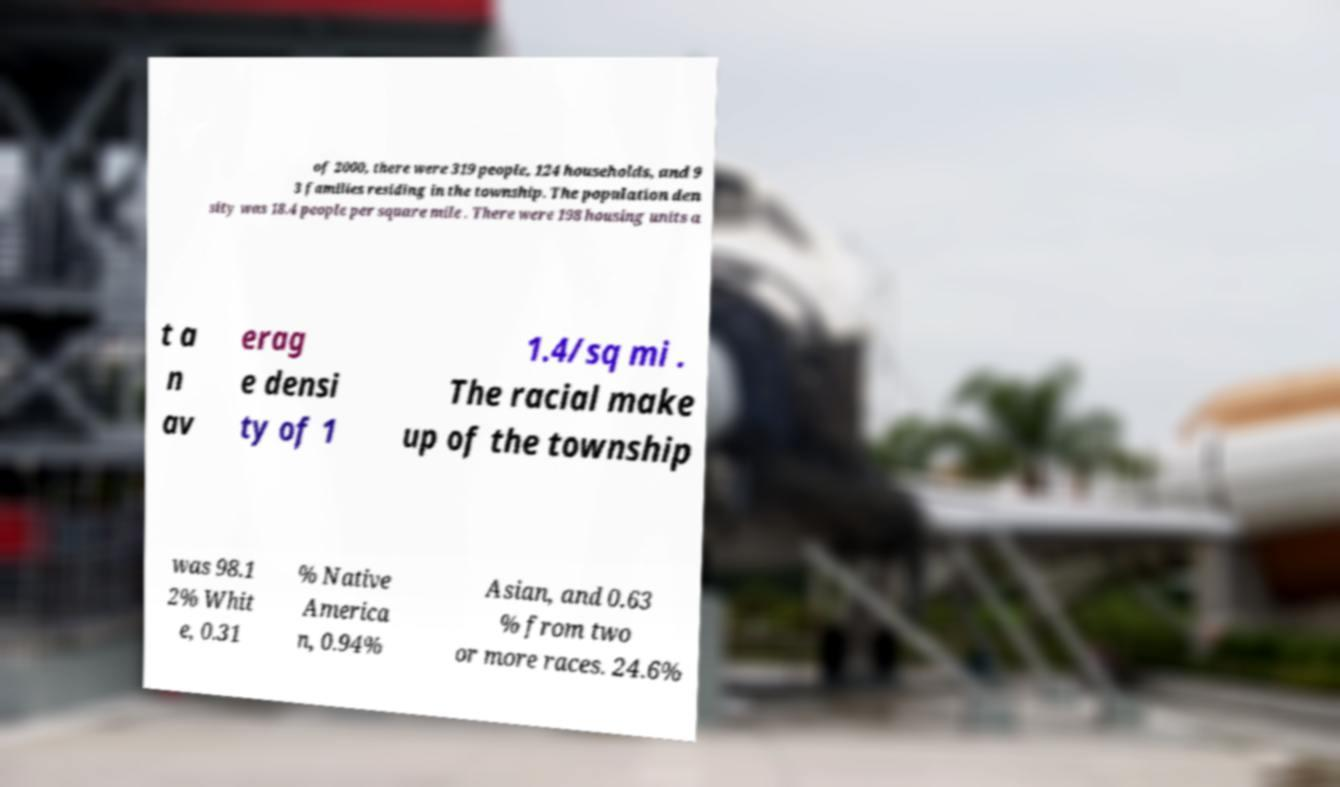For documentation purposes, I need the text within this image transcribed. Could you provide that? of 2000, there were 319 people, 124 households, and 9 3 families residing in the township. The population den sity was 18.4 people per square mile . There were 198 housing units a t a n av erag e densi ty of 1 1.4/sq mi . The racial make up of the township was 98.1 2% Whit e, 0.31 % Native America n, 0.94% Asian, and 0.63 % from two or more races. 24.6% 